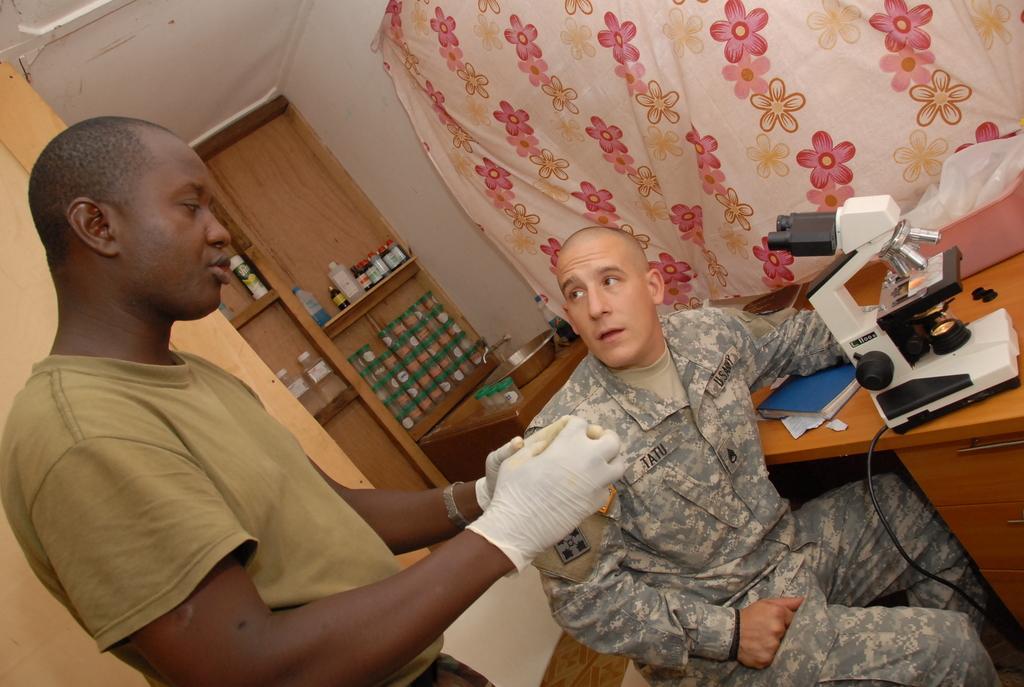How would you summarize this image in a sentence or two? In the picture we can see two men, one man is standing and one man is sitting near the table, he is in army uniform and on the table, we can see a microscope and a book under his hand and behind him we can see a rack with some medicine bottles and into the wall we can see a curtain with some flower designs on it. 